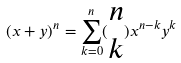Convert formula to latex. <formula><loc_0><loc_0><loc_500><loc_500>( x + y ) ^ { n } = \sum _ { k = 0 } ^ { n } ( \begin{matrix} n \\ k \end{matrix} ) x ^ { n - k } y ^ { k }</formula> 